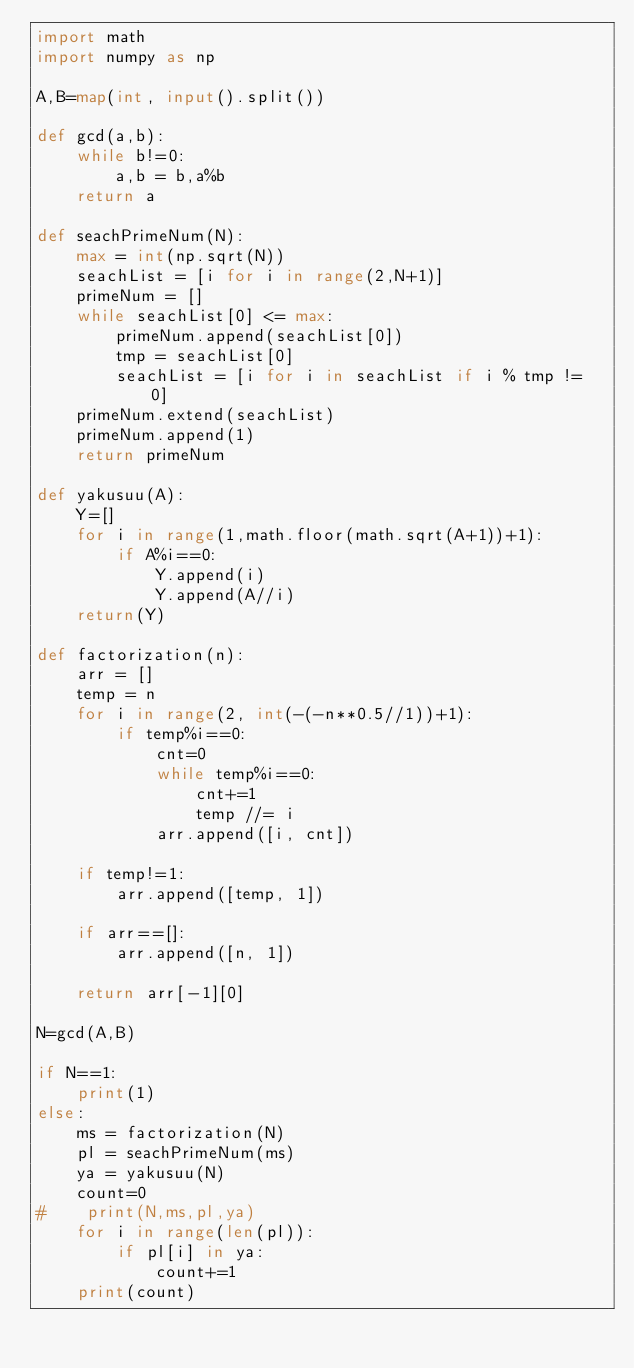Convert code to text. <code><loc_0><loc_0><loc_500><loc_500><_Python_>import math
import numpy as np

A,B=map(int, input().split())

def gcd(a,b):
    while b!=0:
        a,b = b,a%b
    return a

def seachPrimeNum(N):
    max = int(np.sqrt(N))
    seachList = [i for i in range(2,N+1)]
    primeNum = []
    while seachList[0] <= max:
        primeNum.append(seachList[0])
        tmp = seachList[0]
        seachList = [i for i in seachList if i % tmp != 0]
    primeNum.extend(seachList)
    primeNum.append(1)
    return primeNum

def yakusuu(A):
    Y=[]
    for i in range(1,math.floor(math.sqrt(A+1))+1):
        if A%i==0:
            Y.append(i)
            Y.append(A//i)
    return(Y)

def factorization(n):
    arr = []
    temp = n
    for i in range(2, int(-(-n**0.5//1))+1):
        if temp%i==0:
            cnt=0
            while temp%i==0:
                cnt+=1
                temp //= i
            arr.append([i, cnt])

    if temp!=1:
        arr.append([temp, 1])

    if arr==[]:
        arr.append([n, 1])

    return arr[-1][0]

N=gcd(A,B)

if N==1:
    print(1)
else:
    ms = factorization(N)
    pl = seachPrimeNum(ms)
    ya = yakusuu(N)
    count=0
#    print(N,ms,pl,ya)
    for i in range(len(pl)):
        if pl[i] in ya:
            count+=1
    print(count)</code> 